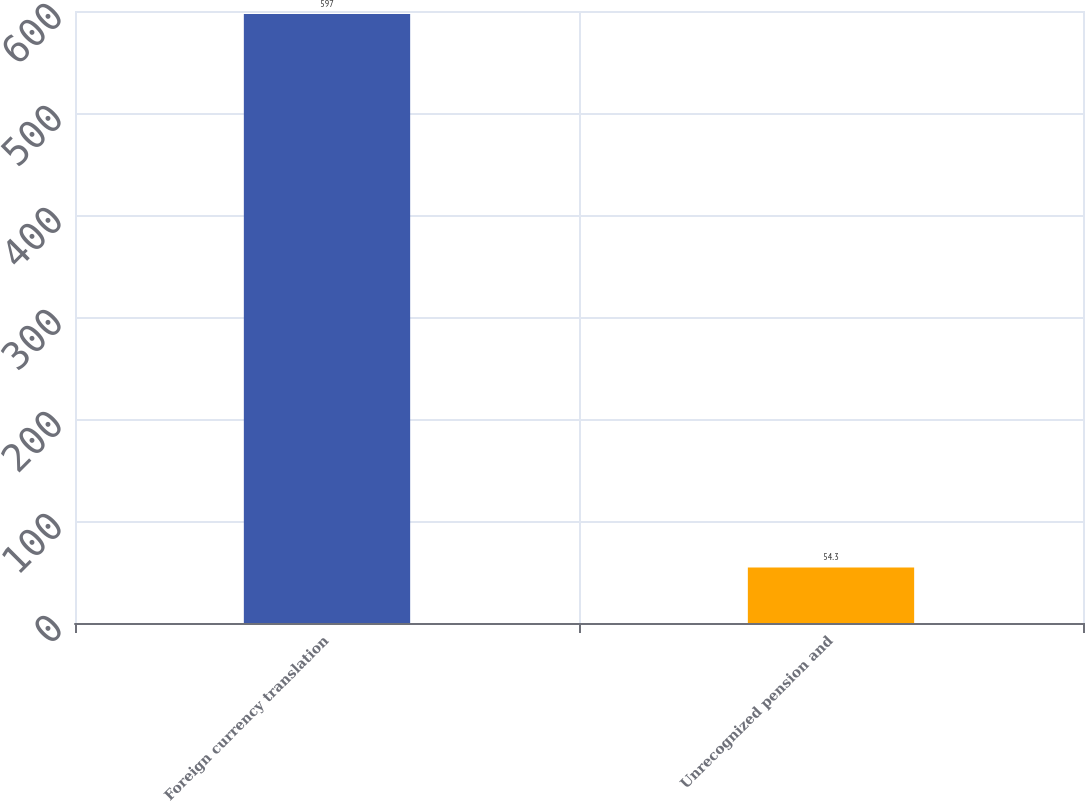Convert chart. <chart><loc_0><loc_0><loc_500><loc_500><bar_chart><fcel>Foreign currency translation<fcel>Unrecognized pension and<nl><fcel>597<fcel>54.3<nl></chart> 